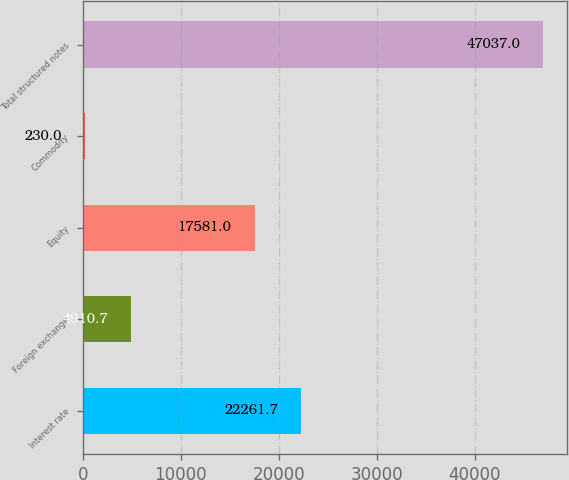Convert chart to OTSL. <chart><loc_0><loc_0><loc_500><loc_500><bar_chart><fcel>Interest rate<fcel>Foreign exchange<fcel>Equity<fcel>Commodity<fcel>Total structured notes<nl><fcel>22261.7<fcel>4910.7<fcel>17581<fcel>230<fcel>47037<nl></chart> 